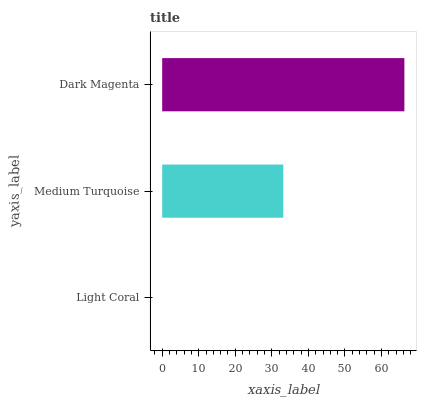Is Light Coral the minimum?
Answer yes or no. Yes. Is Dark Magenta the maximum?
Answer yes or no. Yes. Is Medium Turquoise the minimum?
Answer yes or no. No. Is Medium Turquoise the maximum?
Answer yes or no. No. Is Medium Turquoise greater than Light Coral?
Answer yes or no. Yes. Is Light Coral less than Medium Turquoise?
Answer yes or no. Yes. Is Light Coral greater than Medium Turquoise?
Answer yes or no. No. Is Medium Turquoise less than Light Coral?
Answer yes or no. No. Is Medium Turquoise the high median?
Answer yes or no. Yes. Is Medium Turquoise the low median?
Answer yes or no. Yes. Is Dark Magenta the high median?
Answer yes or no. No. Is Light Coral the low median?
Answer yes or no. No. 